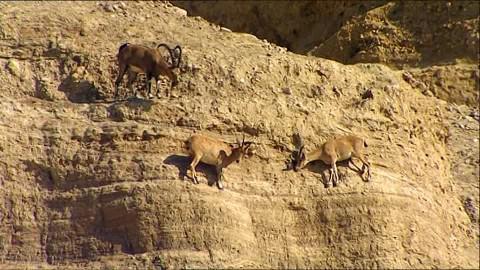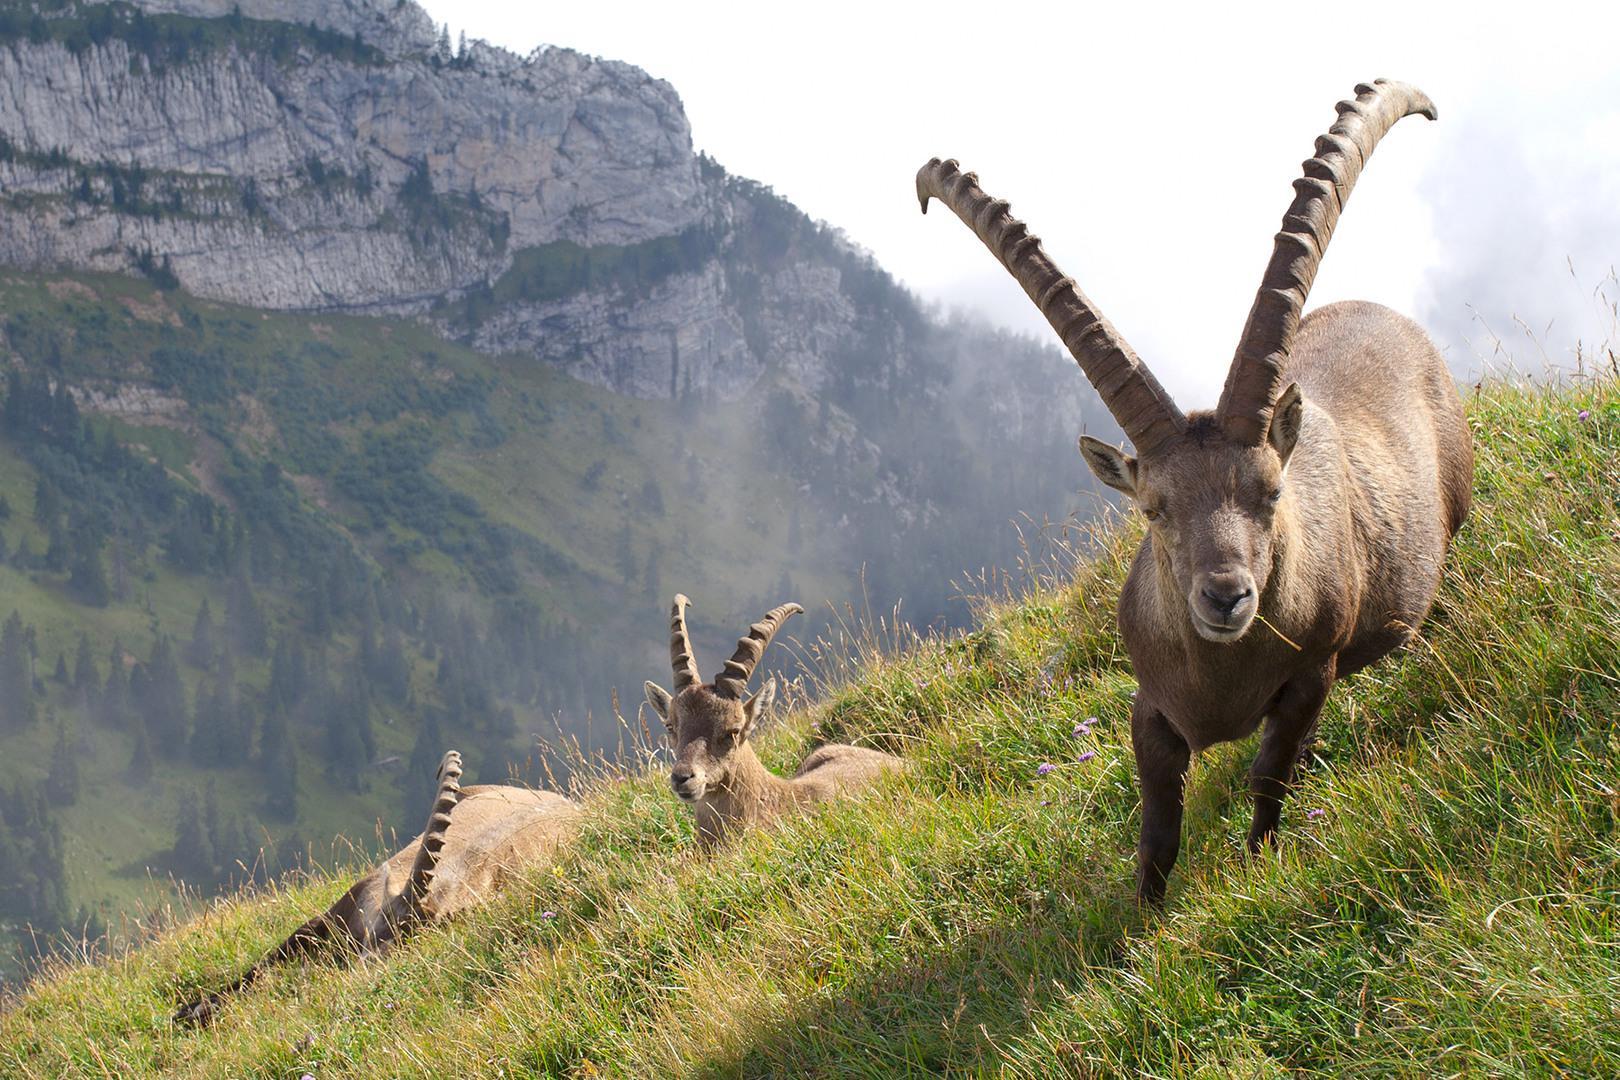The first image is the image on the left, the second image is the image on the right. Given the left and right images, does the statement "Each image depicts exactly one long-horned hooved animal." hold true? Answer yes or no. No. 